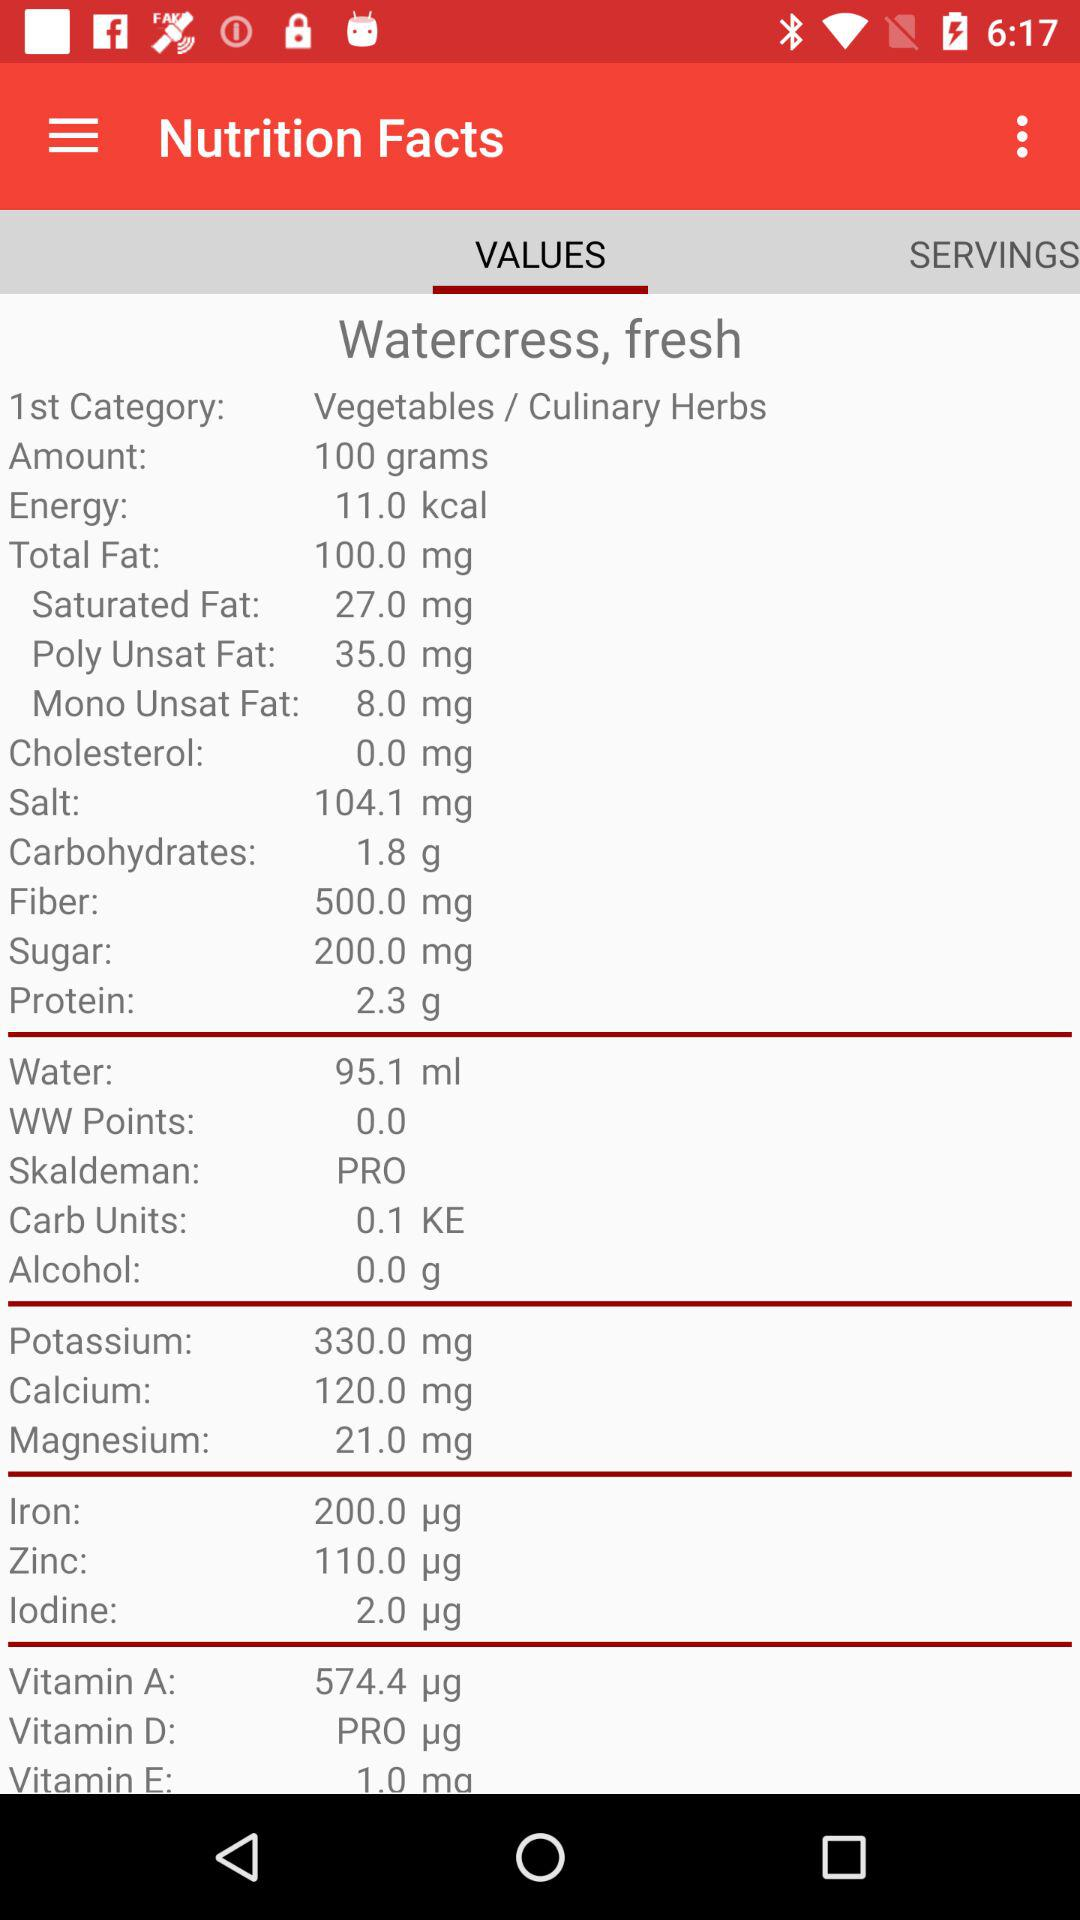How much vitamin A is there? There are 574.4 micrograms of vitamin A. 